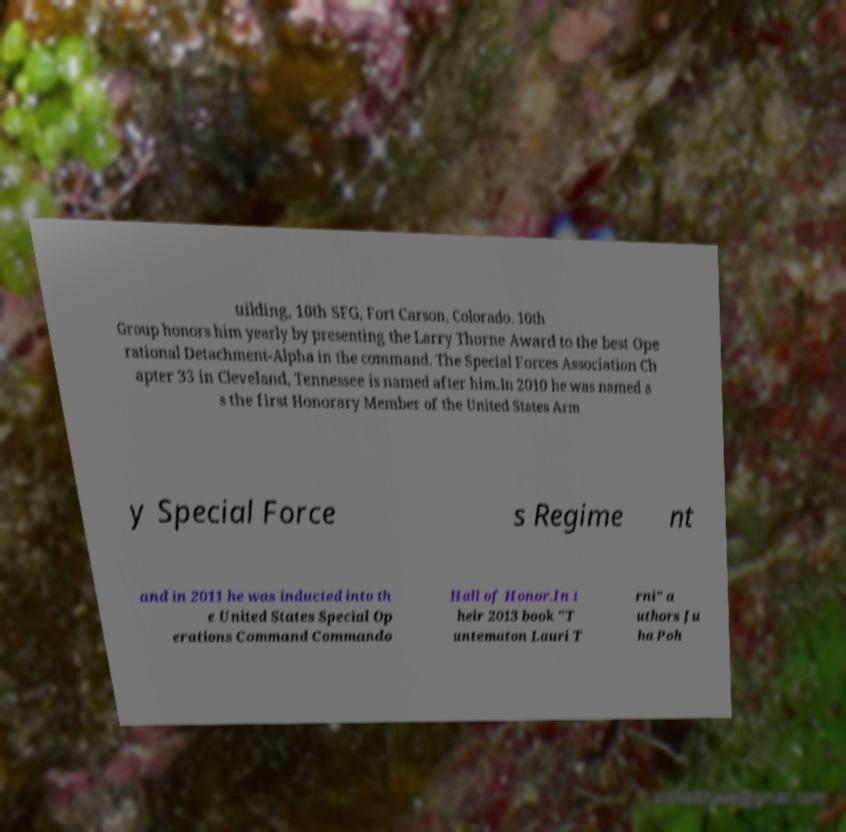Could you extract and type out the text from this image? uilding, 10th SFG, Fort Carson, Colorado. 10th Group honors him yearly by presenting the Larry Thorne Award to the best Ope rational Detachment-Alpha in the command. The Special Forces Association Ch apter 33 in Cleveland, Tennessee is named after him.In 2010 he was named a s the first Honorary Member of the United States Arm y Special Force s Regime nt and in 2011 he was inducted into th e United States Special Op erations Command Commando Hall of Honor.In t heir 2013 book "T untematon Lauri T rni" a uthors Ju ha Poh 